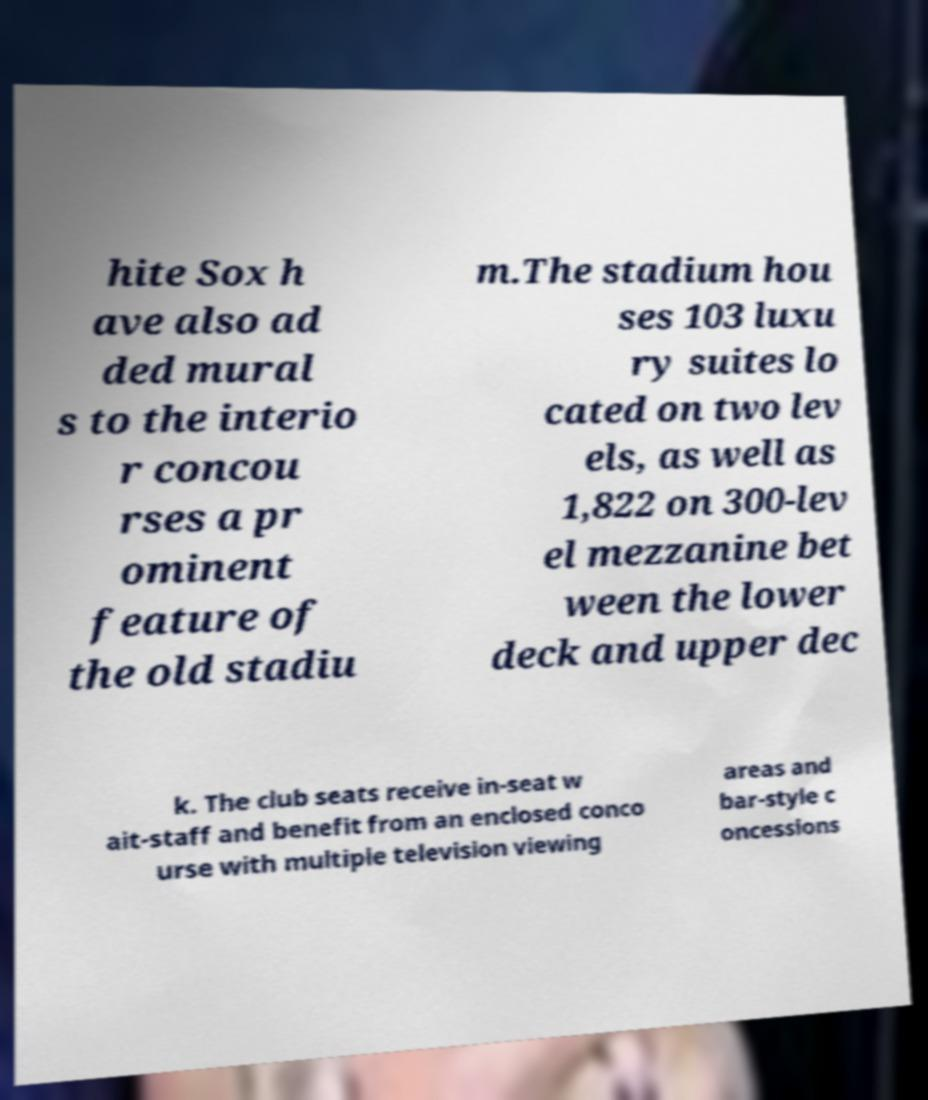Can you read and provide the text displayed in the image?This photo seems to have some interesting text. Can you extract and type it out for me? hite Sox h ave also ad ded mural s to the interio r concou rses a pr ominent feature of the old stadiu m.The stadium hou ses 103 luxu ry suites lo cated on two lev els, as well as 1,822 on 300-lev el mezzanine bet ween the lower deck and upper dec k. The club seats receive in-seat w ait-staff and benefit from an enclosed conco urse with multiple television viewing areas and bar-style c oncessions 